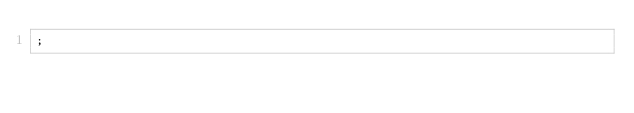<code> <loc_0><loc_0><loc_500><loc_500><_SQL_>;


</code> 